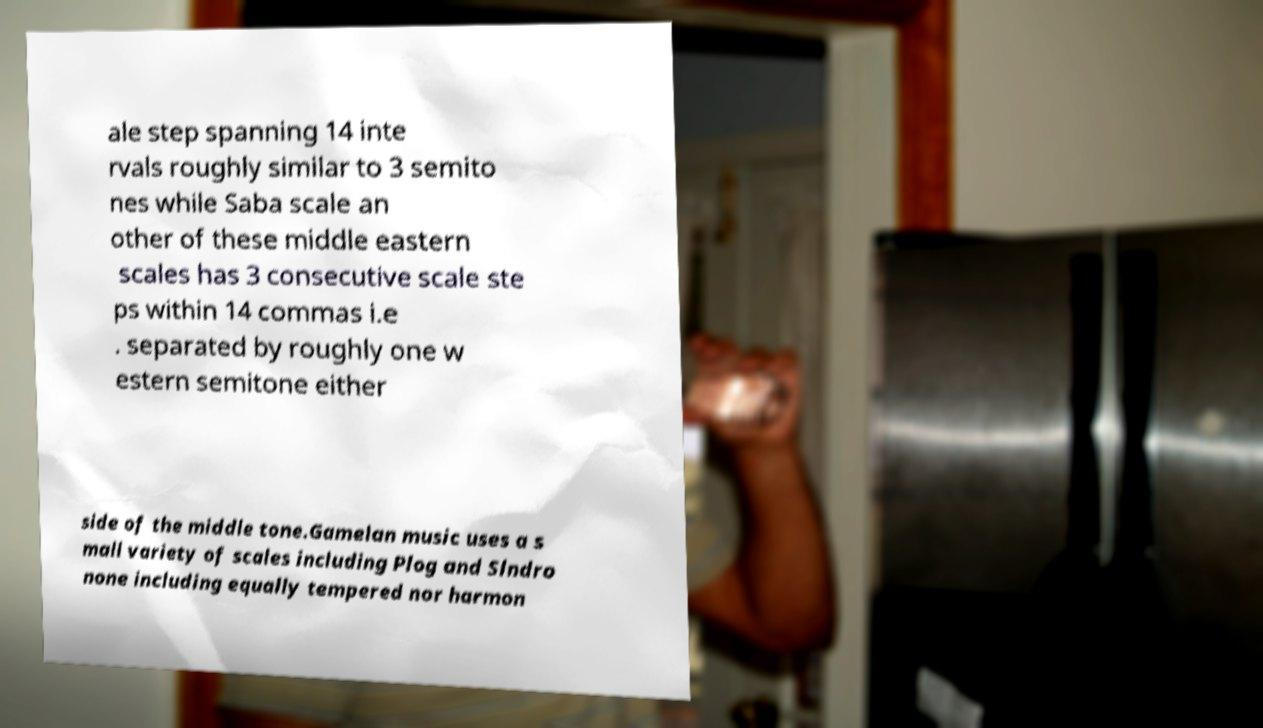Can you read and provide the text displayed in the image?This photo seems to have some interesting text. Can you extract and type it out for me? ale step spanning 14 inte rvals roughly similar to 3 semito nes while Saba scale an other of these middle eastern scales has 3 consecutive scale ste ps within 14 commas i.e . separated by roughly one w estern semitone either side of the middle tone.Gamelan music uses a s mall variety of scales including Plog and Slndro none including equally tempered nor harmon 